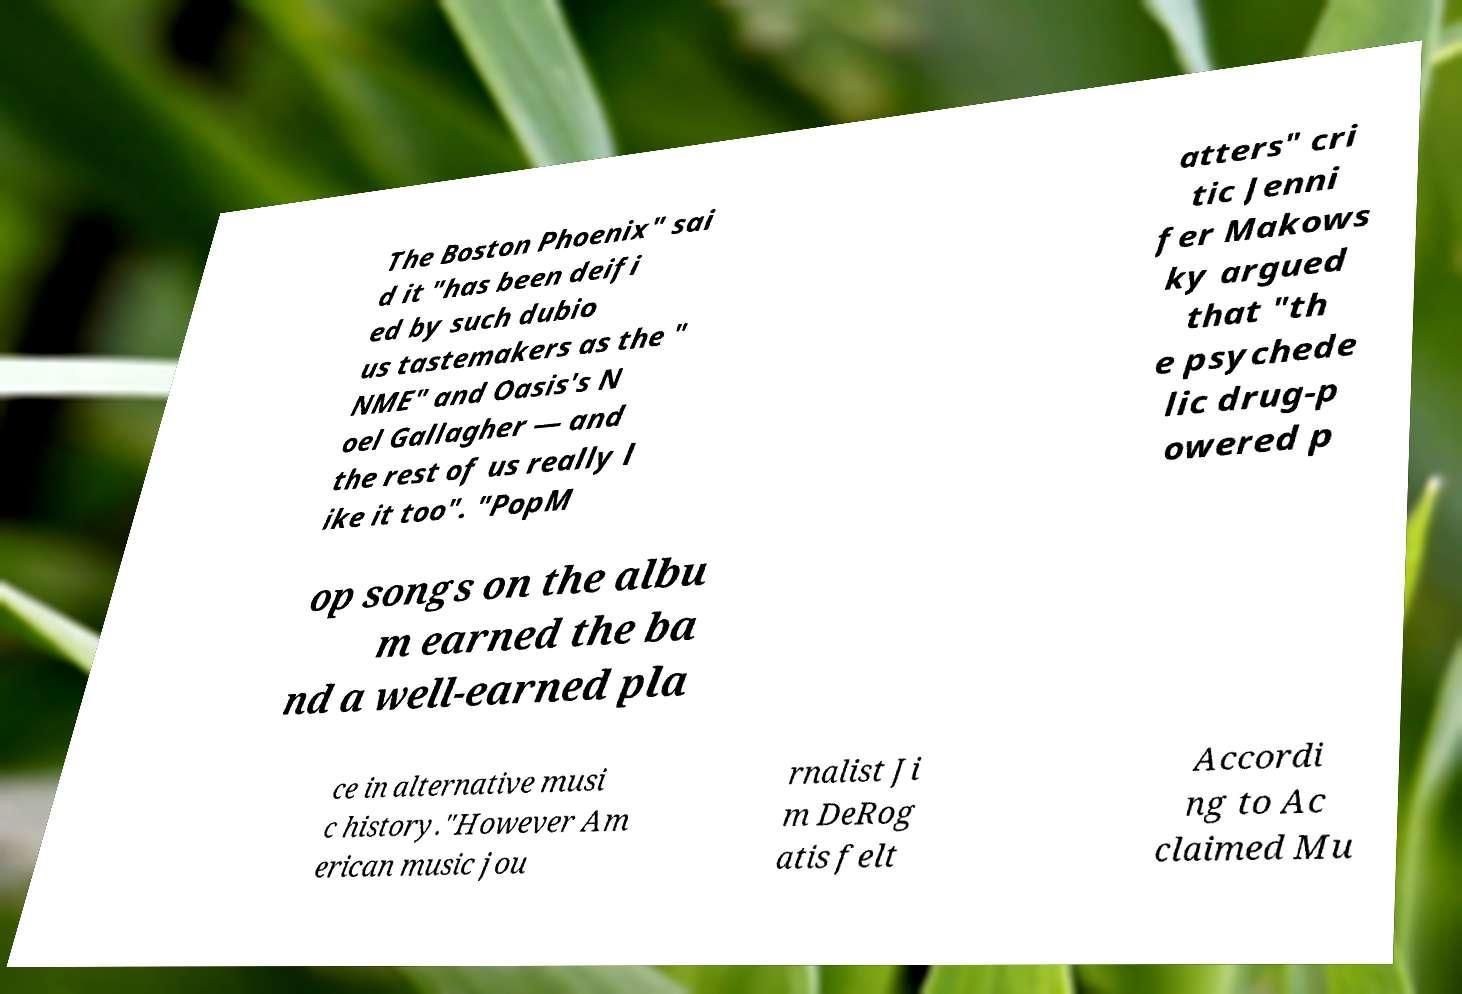Please identify and transcribe the text found in this image. The Boston Phoenix" sai d it "has been deifi ed by such dubio us tastemakers as the " NME" and Oasis's N oel Gallagher — and the rest of us really l ike it too". "PopM atters" cri tic Jenni fer Makows ky argued that "th e psychede lic drug-p owered p op songs on the albu m earned the ba nd a well-earned pla ce in alternative musi c history."However Am erican music jou rnalist Ji m DeRog atis felt Accordi ng to Ac claimed Mu 